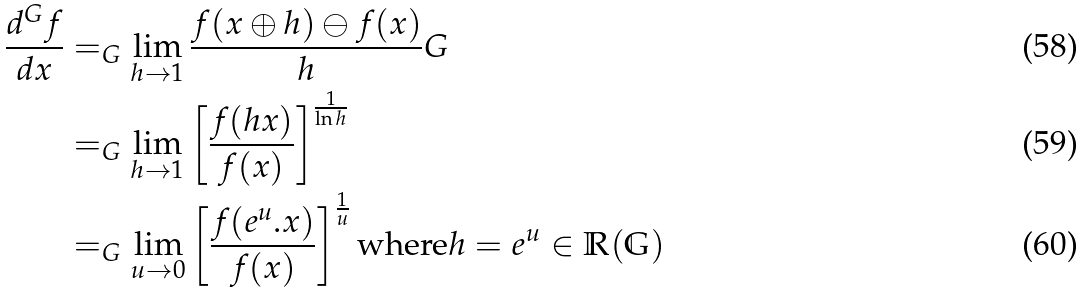<formula> <loc_0><loc_0><loc_500><loc_500>\frac { d ^ { G } f } { d x } & = _ { G } \lim _ { h \rightarrow 1 } \frac { f ( x \oplus h ) \ominus f ( x ) } { h } G \\ & = _ { G } \lim _ { h \rightarrow 1 } \left [ \frac { f ( h x ) } { f ( x ) } \right ] ^ { \frac { 1 } { \ln h } } \\ & = _ { G } \lim _ { u \rightarrow 0 } \left [ \frac { f ( e ^ { u } . x ) } { f ( x ) } \right ] ^ { \frac { 1 } { u } } \text {where} h = e ^ { u } \in \mathbb { R ( G ) } \</formula> 